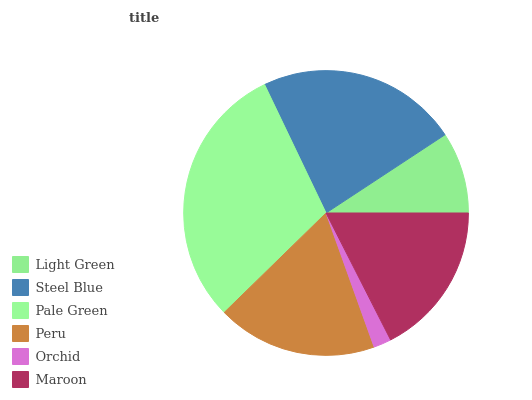Is Orchid the minimum?
Answer yes or no. Yes. Is Pale Green the maximum?
Answer yes or no. Yes. Is Steel Blue the minimum?
Answer yes or no. No. Is Steel Blue the maximum?
Answer yes or no. No. Is Steel Blue greater than Light Green?
Answer yes or no. Yes. Is Light Green less than Steel Blue?
Answer yes or no. Yes. Is Light Green greater than Steel Blue?
Answer yes or no. No. Is Steel Blue less than Light Green?
Answer yes or no. No. Is Peru the high median?
Answer yes or no. Yes. Is Maroon the low median?
Answer yes or no. Yes. Is Light Green the high median?
Answer yes or no. No. Is Orchid the low median?
Answer yes or no. No. 